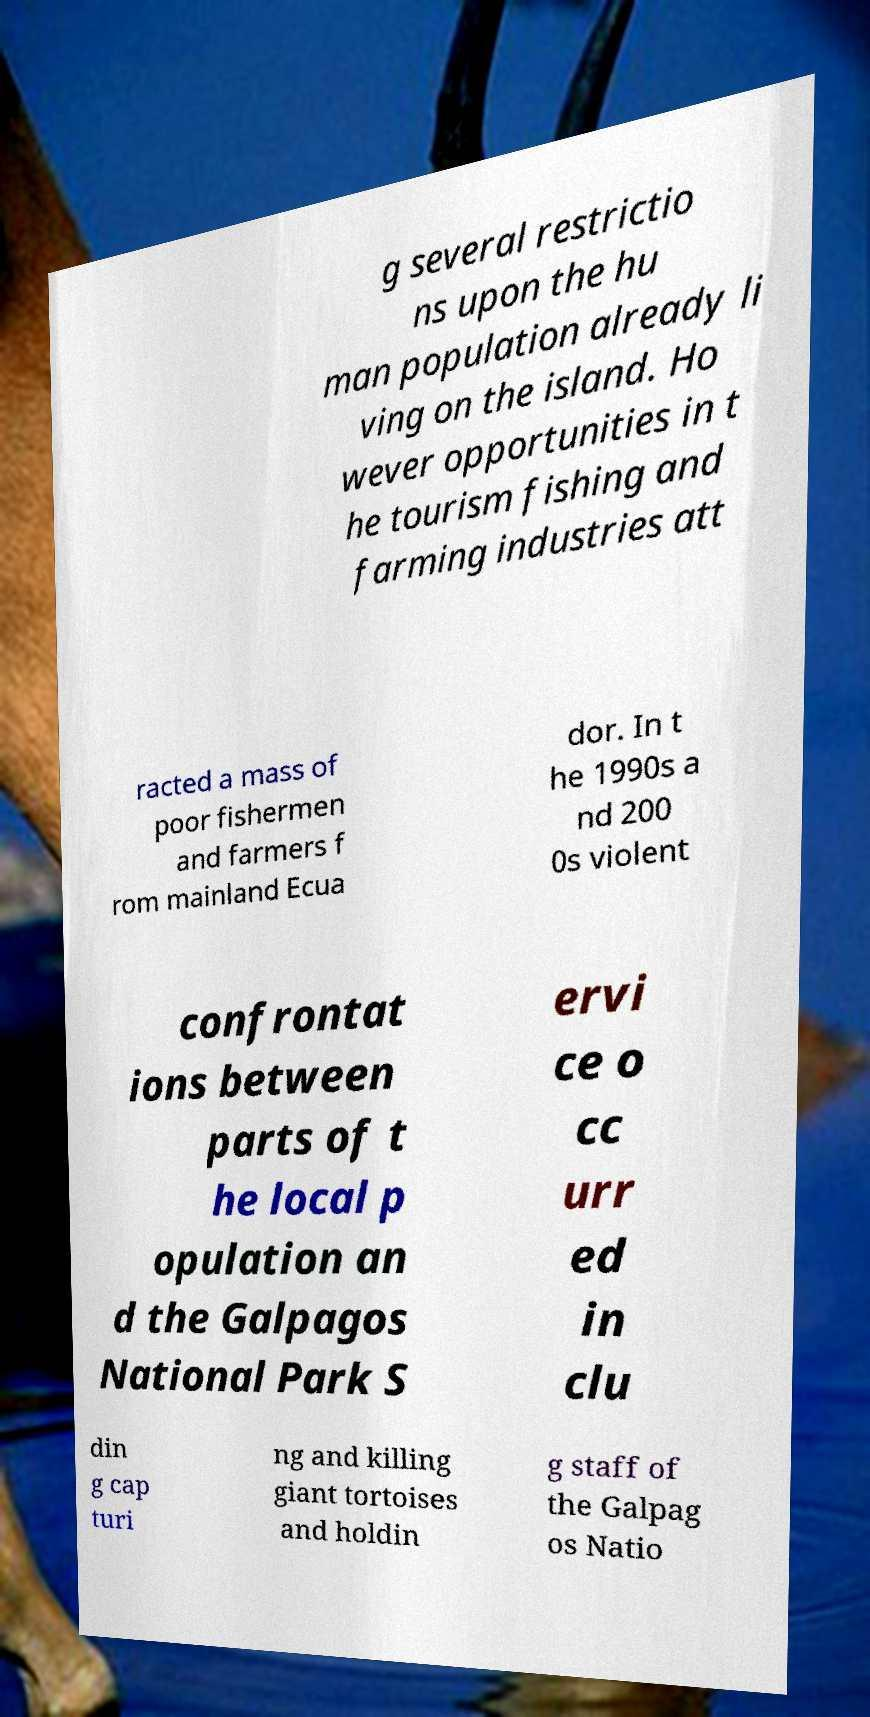There's text embedded in this image that I need extracted. Can you transcribe it verbatim? g several restrictio ns upon the hu man population already li ving on the island. Ho wever opportunities in t he tourism fishing and farming industries att racted a mass of poor fishermen and farmers f rom mainland Ecua dor. In t he 1990s a nd 200 0s violent confrontat ions between parts of t he local p opulation an d the Galpagos National Park S ervi ce o cc urr ed in clu din g cap turi ng and killing giant tortoises and holdin g staff of the Galpag os Natio 